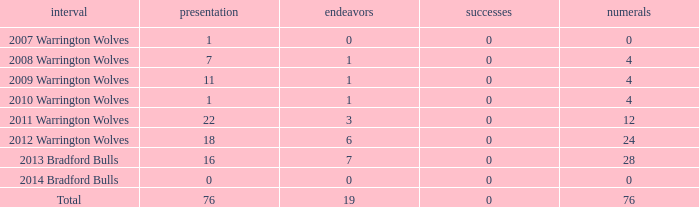What is the lowest appearance when goals is more than 0? None. 